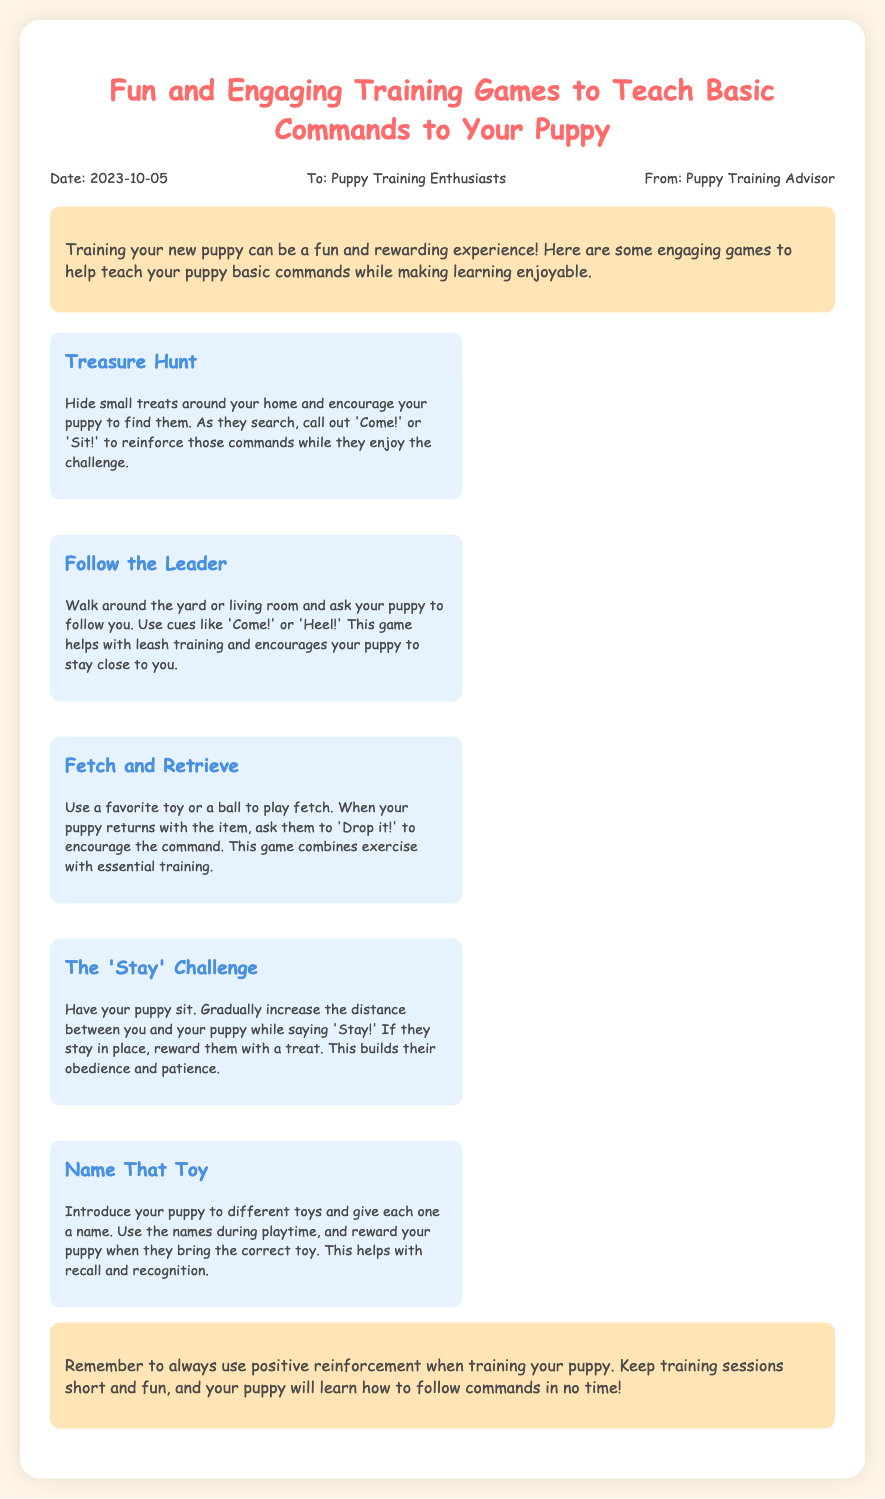What is the title of the memo? The title of the memo is clearly stated in the document as "Fun and Engaging Training Games to Teach Basic Commands to Your Puppy."
Answer: Fun and Engaging Training Games to Teach Basic Commands to Your Puppy Who is the memo addressed to? The memo specifies the audience it is directed towards, which is "Puppy Training Enthusiasts."
Answer: Puppy Training Enthusiasts What is the date of the memo? The date of the memo is provided in the header section, specifically "2023-10-05."
Answer: 2023-10-05 How many games are listed in the document? The document details five engaging training games designed for puppy training.
Answer: 5 What command is used in the 'Stay' Challenge? The command given in the 'Stay' Challenge is explicitly stated in the text, which is "Stay!"
Answer: Stay! What is one benefit of the Treasure Hunt game? The game of Treasure Hunt promotes learning of the commands 'Come!' and 'Sit!' while providing a fun challenge.
Answer: Learning commands What is emphasized in the conclusion? The conclusion highlights the importance of using "positive reinforcement" during puppy training sessions.
Answer: Positive reinforcement What should you reward your puppy with in the 'Stay' Challenge? In the 'Stay' Challenge, it is mentioned that if the puppy stays in place, they should be rewarded with a "treat."
Answer: Treat What is the purpose of the Name That Toy game? The purpose of the Name That Toy game is to help with "recall and recognition" of the toys.
Answer: Recall and recognition 